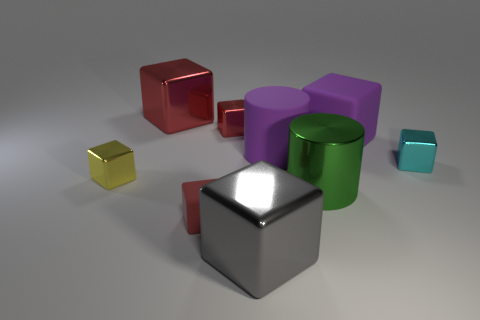The cyan object that is the same material as the gray block is what size?
Offer a very short reply. Small. What number of small shiny blocks are the same color as the metal cylinder?
Your answer should be compact. 0. Is the number of green cylinders that are in front of the small cyan metallic object less than the number of big green shiny objects that are on the left side of the purple matte cylinder?
Ensure brevity in your answer.  No. Is the shape of the small rubber object to the right of the small yellow object the same as  the big green thing?
Provide a short and direct response. No. Are the small red object that is to the right of the tiny rubber cube and the big purple block made of the same material?
Offer a very short reply. No. What is the material of the big cylinder that is on the right side of the cylinder behind the tiny object that is on the right side of the metallic cylinder?
Offer a terse response. Metal. How many other things are the same shape as the small cyan thing?
Your answer should be compact. 6. What is the color of the big rubber object that is on the left side of the large green cylinder?
Provide a short and direct response. Purple. How many large cylinders are to the left of the big cylinder in front of the large cylinder that is behind the green shiny cylinder?
Offer a terse response. 1. There is a matte object that is to the right of the green metal cylinder; how many tiny metallic things are behind it?
Offer a terse response. 1. 